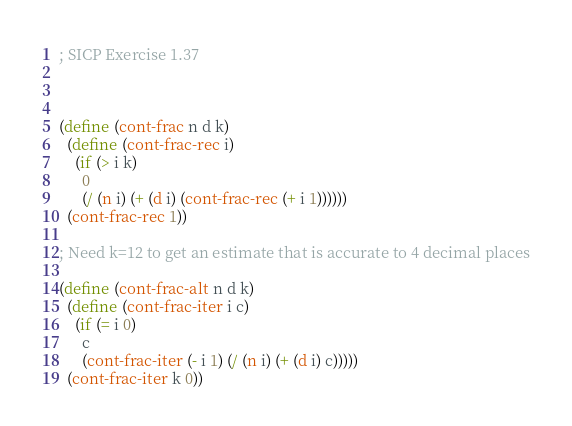<code> <loc_0><loc_0><loc_500><loc_500><_Scheme_>; SICP Exercise 1.37



(define (cont-frac n d k)
  (define (cont-frac-rec i)
    (if (> i k)
      0
      (/ (n i) (+ (d i) (cont-frac-rec (+ i 1))))))
  (cont-frac-rec 1))

; Need k=12 to get an estimate that is accurate to 4 decimal places

(define (cont-frac-alt n d k)
  (define (cont-frac-iter i c)
    (if (= i 0)
      c
      (cont-frac-iter (- i 1) (/ (n i) (+ (d i) c)))))
  (cont-frac-iter k 0))
</code> 